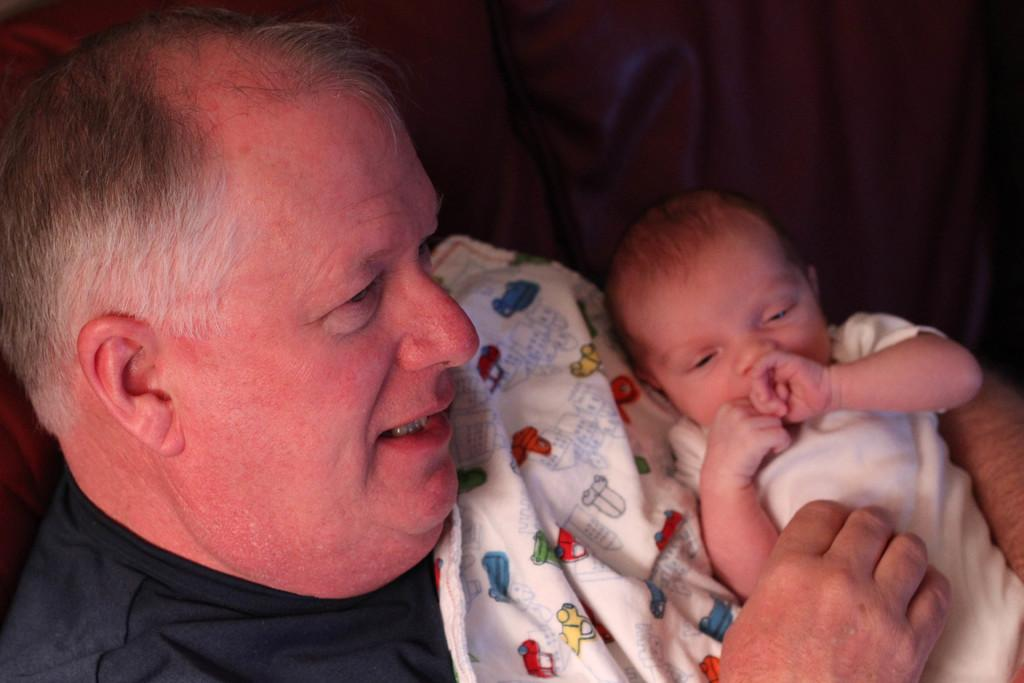Who is the main subject in the image? There is an old man in the image. What is the old man doing in the image? The old man is holding a baby. How is the baby dressed or covered in the image? The baby is wrapped in a blanket. What is the purpose of the second blanket in the image? There is a blanket under the baby, possibly for support or comfort. What type of grass can be seen growing in the image? There is no grass present in the image. What subject is the old man teaching in the image? The image does not depict any teaching or educational activity. 